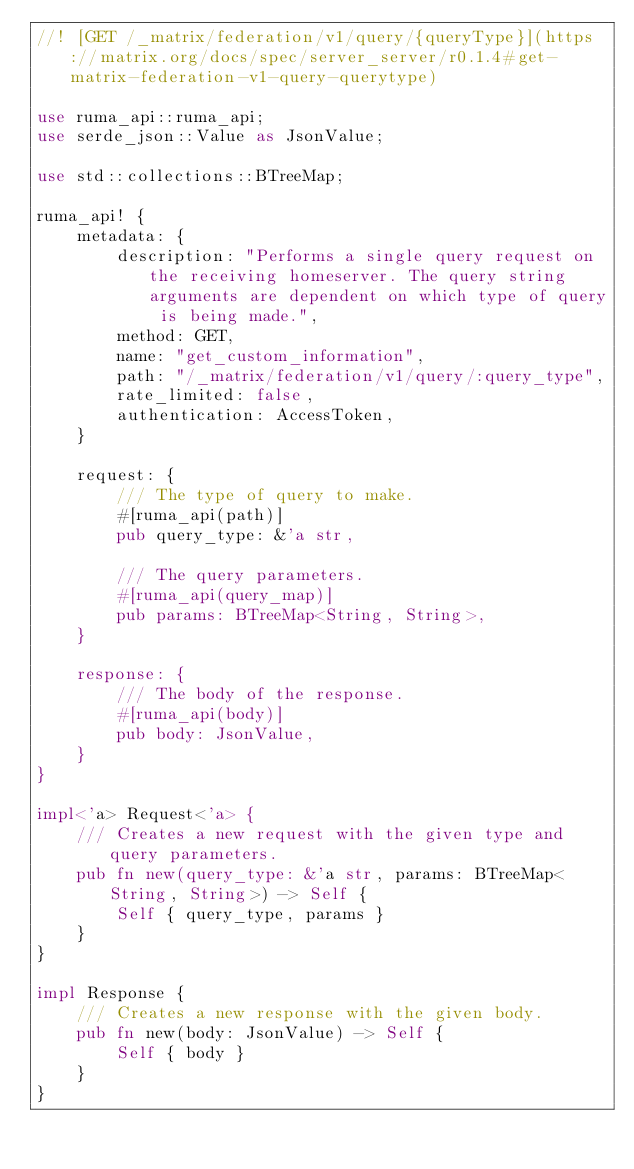Convert code to text. <code><loc_0><loc_0><loc_500><loc_500><_Rust_>//! [GET /_matrix/federation/v1/query/{queryType}](https://matrix.org/docs/spec/server_server/r0.1.4#get-matrix-federation-v1-query-querytype)

use ruma_api::ruma_api;
use serde_json::Value as JsonValue;

use std::collections::BTreeMap;

ruma_api! {
    metadata: {
        description: "Performs a single query request on the receiving homeserver. The query string arguments are dependent on which type of query is being made.",
        method: GET,
        name: "get_custom_information",
        path: "/_matrix/federation/v1/query/:query_type",
        rate_limited: false,
        authentication: AccessToken,
    }

    request: {
        /// The type of query to make.
        #[ruma_api(path)]
        pub query_type: &'a str,

        /// The query parameters.
        #[ruma_api(query_map)]
        pub params: BTreeMap<String, String>,
    }

    response: {
        /// The body of the response.
        #[ruma_api(body)]
        pub body: JsonValue,
    }
}

impl<'a> Request<'a> {
    /// Creates a new request with the given type and query parameters.
    pub fn new(query_type: &'a str, params: BTreeMap<String, String>) -> Self {
        Self { query_type, params }
    }
}

impl Response {
    /// Creates a new response with the given body.
    pub fn new(body: JsonValue) -> Self {
        Self { body }
    }
}
</code> 